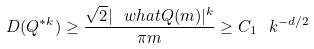<formula> <loc_0><loc_0><loc_500><loc_500>D ( Q ^ { * k } ) \geq \frac { \sqrt { 2 } | \ w h a t { Q } ( m ) | ^ { k } } { \pi m } \geq C _ { 1 } \ k ^ { - d / 2 }</formula> 